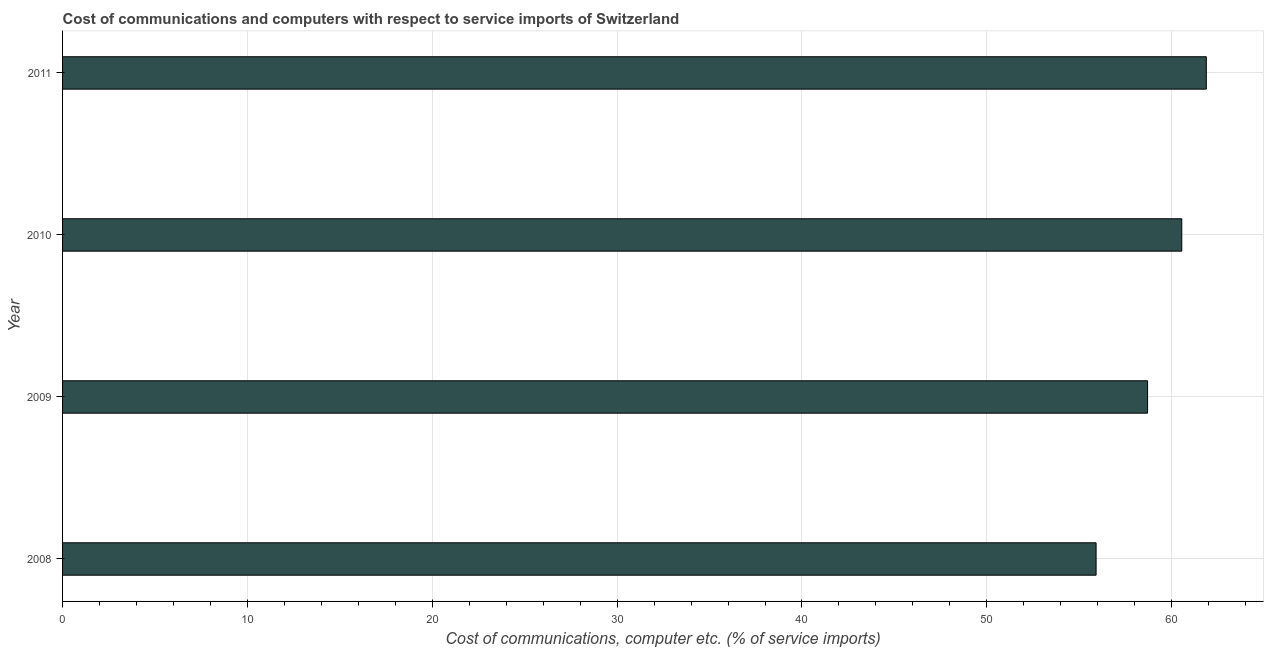Does the graph contain grids?
Offer a very short reply. Yes. What is the title of the graph?
Provide a short and direct response. Cost of communications and computers with respect to service imports of Switzerland. What is the label or title of the X-axis?
Offer a terse response. Cost of communications, computer etc. (% of service imports). What is the cost of communications and computer in 2010?
Your answer should be very brief. 60.54. Across all years, what is the maximum cost of communications and computer?
Provide a short and direct response. 61.87. Across all years, what is the minimum cost of communications and computer?
Make the answer very short. 55.91. In which year was the cost of communications and computer minimum?
Keep it short and to the point. 2008. What is the sum of the cost of communications and computer?
Your response must be concise. 237.02. What is the difference between the cost of communications and computer in 2010 and 2011?
Offer a terse response. -1.33. What is the average cost of communications and computer per year?
Your response must be concise. 59.26. What is the median cost of communications and computer?
Offer a terse response. 59.62. In how many years, is the cost of communications and computer greater than 22 %?
Your answer should be very brief. 4. What is the ratio of the cost of communications and computer in 2008 to that in 2011?
Your response must be concise. 0.9. What is the difference between the highest and the second highest cost of communications and computer?
Your response must be concise. 1.33. Is the sum of the cost of communications and computer in 2010 and 2011 greater than the maximum cost of communications and computer across all years?
Provide a short and direct response. Yes. What is the difference between the highest and the lowest cost of communications and computer?
Provide a succinct answer. 5.96. Are all the bars in the graph horizontal?
Your answer should be compact. Yes. How many years are there in the graph?
Your answer should be compact. 4. What is the difference between two consecutive major ticks on the X-axis?
Your response must be concise. 10. Are the values on the major ticks of X-axis written in scientific E-notation?
Keep it short and to the point. No. What is the Cost of communications, computer etc. (% of service imports) of 2008?
Make the answer very short. 55.91. What is the Cost of communications, computer etc. (% of service imports) in 2009?
Your answer should be compact. 58.7. What is the Cost of communications, computer etc. (% of service imports) in 2010?
Ensure brevity in your answer.  60.54. What is the Cost of communications, computer etc. (% of service imports) in 2011?
Offer a very short reply. 61.87. What is the difference between the Cost of communications, computer etc. (% of service imports) in 2008 and 2009?
Offer a very short reply. -2.79. What is the difference between the Cost of communications, computer etc. (% of service imports) in 2008 and 2010?
Keep it short and to the point. -4.63. What is the difference between the Cost of communications, computer etc. (% of service imports) in 2008 and 2011?
Ensure brevity in your answer.  -5.96. What is the difference between the Cost of communications, computer etc. (% of service imports) in 2009 and 2010?
Make the answer very short. -1.85. What is the difference between the Cost of communications, computer etc. (% of service imports) in 2009 and 2011?
Your response must be concise. -3.18. What is the difference between the Cost of communications, computer etc. (% of service imports) in 2010 and 2011?
Make the answer very short. -1.33. What is the ratio of the Cost of communications, computer etc. (% of service imports) in 2008 to that in 2009?
Your answer should be compact. 0.95. What is the ratio of the Cost of communications, computer etc. (% of service imports) in 2008 to that in 2010?
Ensure brevity in your answer.  0.92. What is the ratio of the Cost of communications, computer etc. (% of service imports) in 2008 to that in 2011?
Ensure brevity in your answer.  0.9. What is the ratio of the Cost of communications, computer etc. (% of service imports) in 2009 to that in 2011?
Provide a succinct answer. 0.95. 